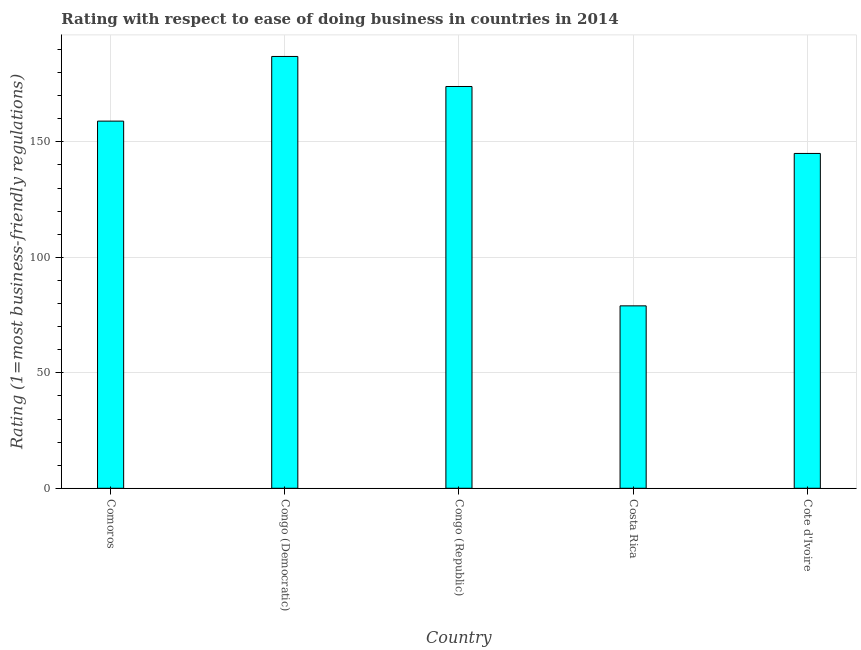Does the graph contain grids?
Your answer should be compact. Yes. What is the title of the graph?
Your answer should be compact. Rating with respect to ease of doing business in countries in 2014. What is the label or title of the X-axis?
Provide a short and direct response. Country. What is the label or title of the Y-axis?
Offer a very short reply. Rating (1=most business-friendly regulations). What is the ease of doing business index in Cote d'Ivoire?
Keep it short and to the point. 145. Across all countries, what is the maximum ease of doing business index?
Provide a short and direct response. 187. Across all countries, what is the minimum ease of doing business index?
Offer a terse response. 79. In which country was the ease of doing business index maximum?
Your answer should be compact. Congo (Democratic). In which country was the ease of doing business index minimum?
Offer a very short reply. Costa Rica. What is the sum of the ease of doing business index?
Provide a short and direct response. 744. What is the difference between the ease of doing business index in Congo (Republic) and Costa Rica?
Provide a short and direct response. 95. What is the average ease of doing business index per country?
Offer a terse response. 148.8. What is the median ease of doing business index?
Give a very brief answer. 159. In how many countries, is the ease of doing business index greater than 120 ?
Your answer should be very brief. 4. What is the ratio of the ease of doing business index in Costa Rica to that in Cote d'Ivoire?
Offer a terse response. 0.55. Is the difference between the ease of doing business index in Comoros and Congo (Republic) greater than the difference between any two countries?
Your response must be concise. No. What is the difference between the highest and the second highest ease of doing business index?
Your answer should be very brief. 13. What is the difference between the highest and the lowest ease of doing business index?
Provide a short and direct response. 108. In how many countries, is the ease of doing business index greater than the average ease of doing business index taken over all countries?
Offer a terse response. 3. How many countries are there in the graph?
Make the answer very short. 5. What is the difference between two consecutive major ticks on the Y-axis?
Ensure brevity in your answer.  50. What is the Rating (1=most business-friendly regulations) of Comoros?
Your answer should be compact. 159. What is the Rating (1=most business-friendly regulations) of Congo (Democratic)?
Ensure brevity in your answer.  187. What is the Rating (1=most business-friendly regulations) of Congo (Republic)?
Offer a very short reply. 174. What is the Rating (1=most business-friendly regulations) of Costa Rica?
Ensure brevity in your answer.  79. What is the Rating (1=most business-friendly regulations) of Cote d'Ivoire?
Your answer should be compact. 145. What is the difference between the Rating (1=most business-friendly regulations) in Comoros and Congo (Democratic)?
Ensure brevity in your answer.  -28. What is the difference between the Rating (1=most business-friendly regulations) in Comoros and Congo (Republic)?
Give a very brief answer. -15. What is the difference between the Rating (1=most business-friendly regulations) in Comoros and Cote d'Ivoire?
Your answer should be compact. 14. What is the difference between the Rating (1=most business-friendly regulations) in Congo (Democratic) and Congo (Republic)?
Your answer should be compact. 13. What is the difference between the Rating (1=most business-friendly regulations) in Congo (Democratic) and Costa Rica?
Offer a terse response. 108. What is the difference between the Rating (1=most business-friendly regulations) in Costa Rica and Cote d'Ivoire?
Provide a succinct answer. -66. What is the ratio of the Rating (1=most business-friendly regulations) in Comoros to that in Congo (Republic)?
Your response must be concise. 0.91. What is the ratio of the Rating (1=most business-friendly regulations) in Comoros to that in Costa Rica?
Your answer should be compact. 2.01. What is the ratio of the Rating (1=most business-friendly regulations) in Comoros to that in Cote d'Ivoire?
Offer a terse response. 1.1. What is the ratio of the Rating (1=most business-friendly regulations) in Congo (Democratic) to that in Congo (Republic)?
Your answer should be compact. 1.07. What is the ratio of the Rating (1=most business-friendly regulations) in Congo (Democratic) to that in Costa Rica?
Give a very brief answer. 2.37. What is the ratio of the Rating (1=most business-friendly regulations) in Congo (Democratic) to that in Cote d'Ivoire?
Offer a very short reply. 1.29. What is the ratio of the Rating (1=most business-friendly regulations) in Congo (Republic) to that in Costa Rica?
Your answer should be very brief. 2.2. What is the ratio of the Rating (1=most business-friendly regulations) in Congo (Republic) to that in Cote d'Ivoire?
Keep it short and to the point. 1.2. What is the ratio of the Rating (1=most business-friendly regulations) in Costa Rica to that in Cote d'Ivoire?
Provide a succinct answer. 0.55. 